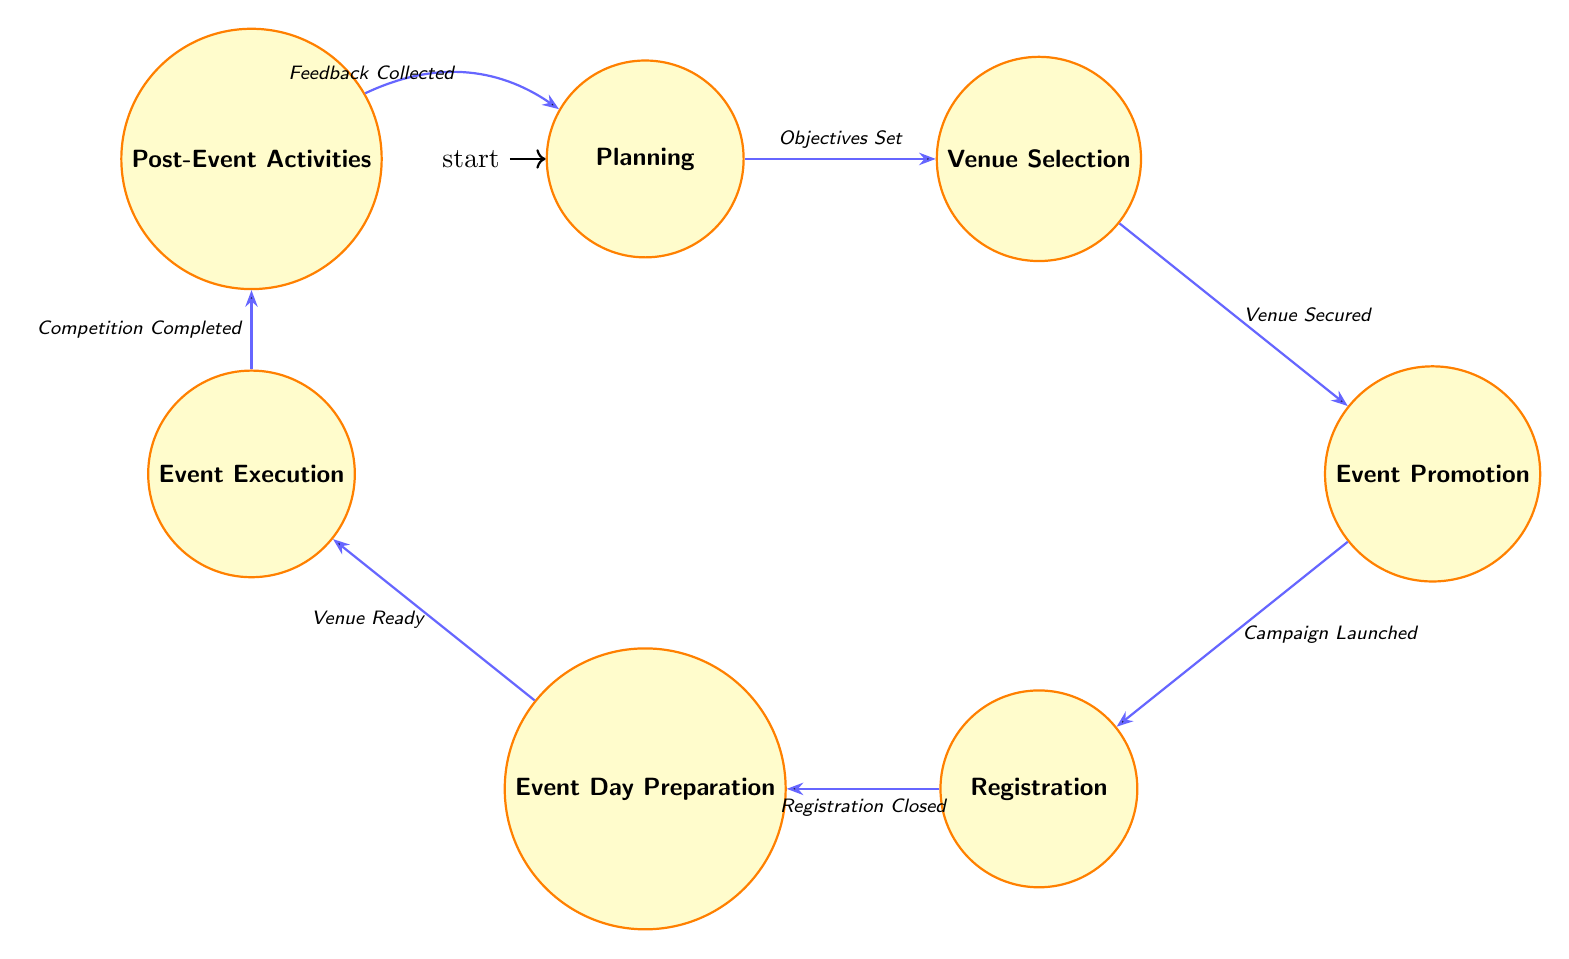What is the first state in the diagram? The diagram shows "Planning" as the initial state, which is clearly indicated as starting point in the flow of the finite state machine.
Answer: Planning How many nodes are present in the diagram? By counting each distinct state represented in the diagram, we observe a total of seven states: Planning, Venue Selection, Event Promotion, Registration, Event Day Preparation, Event Execution, and Post-Event Activities.
Answer: Seven What action is taken during the "Venue Selection" state? The "Venue Selection" state includes the actions: "Select Venue," "Inspect Facilities," and "Negotiate Contracts," which are specified within that state's list of actions.
Answer: Select Venue, Inspect Facilities, Negotiate Contracts What is required to transition from "Event Day Preparation" to "Event Execution"? The transition from "Event Day Preparation" to "Event Execution" occurs once the conditions are met, specifically when the venue is ready, equipment is arranged, and volunteers have been briefed.
Answer: Venue Ready, Equipment Arranged, Volunteers Briefed What happens after the "Event Execution" state? Following the "Event Execution" state, the diagram illustrates that the next state is "Post-Event Activities," indicating that this is the immediate action following the completion of the execution stage of the event.
Answer: Post-Event Activities How does one transition from "Planning" to "Venue Selection"? The transition from "Planning" to "Venue Selection" occurs when the objectives are set, the organizing committee is formed, and sponsorships are secured, explicitly stated in the conditions for this transition.
Answer: Objectives Set, Committee Formed, Sponsorships Secured What determines when the "Registration" state can begin? The "Registration" state can begin only after the promotion campaign has been launched, which is a prerequisite condition for transitioning to this state according to the diagram.
Answer: Promotion Campaign Launched 